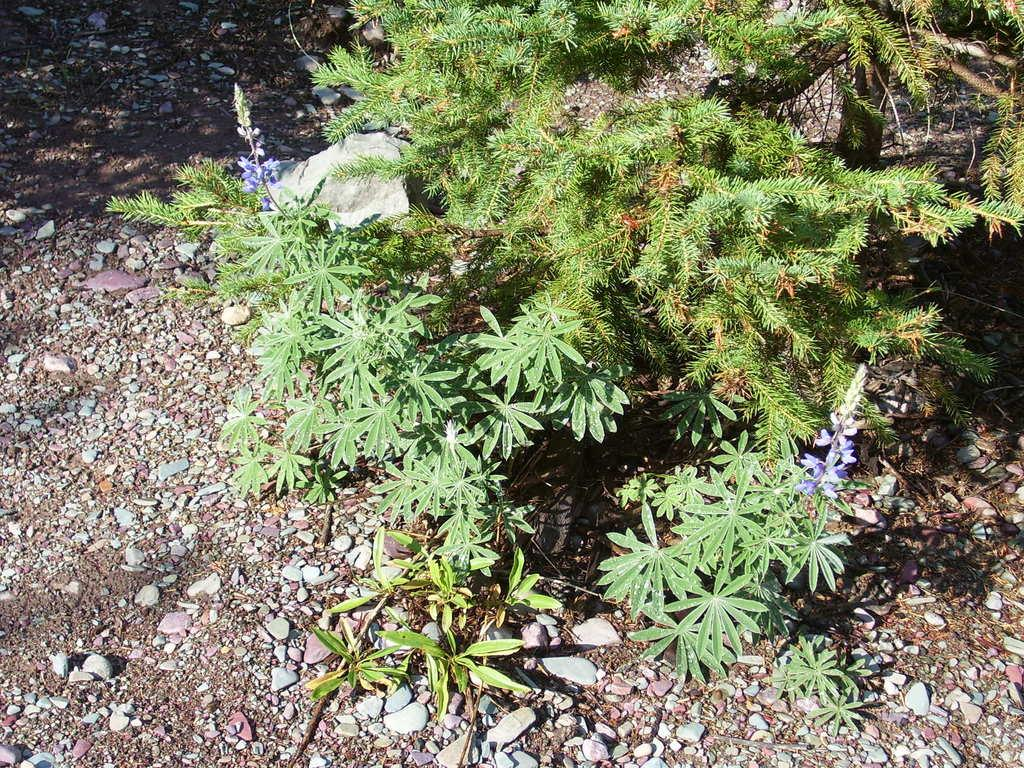What type of vegetation can be seen in the image? There are plants, flowers, and leaves visible in the image. What other elements can be found in the image? There are rocks and stones in the image. What is the base material for the plants in the image? Soil is visible in the image. Do the fairies in the image prefer mint or basil? There are no fairies present in the image, so it is impossible to determine their preferences. 